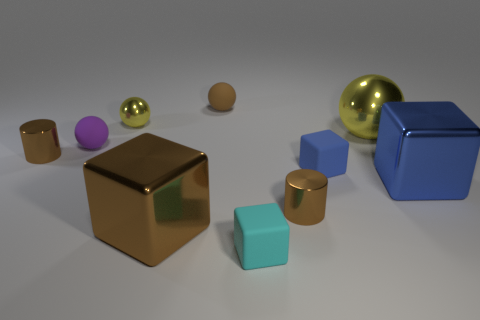Subtract all blue cubes. How many were subtracted if there are1blue cubes left? 1 Subtract all red spheres. Subtract all cyan cylinders. How many spheres are left? 4 Subtract all blocks. How many objects are left? 6 Subtract all big yellow balls. Subtract all tiny rubber blocks. How many objects are left? 7 Add 6 small yellow metal balls. How many small yellow metal balls are left? 7 Add 6 cyan things. How many cyan things exist? 7 Subtract 1 purple balls. How many objects are left? 9 